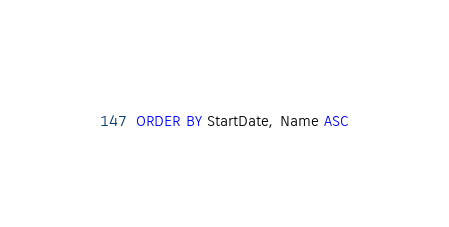Convert code to text. <code><loc_0><loc_0><loc_500><loc_500><_SQL_>ORDER BY StartDate, Name ASC

</code> 